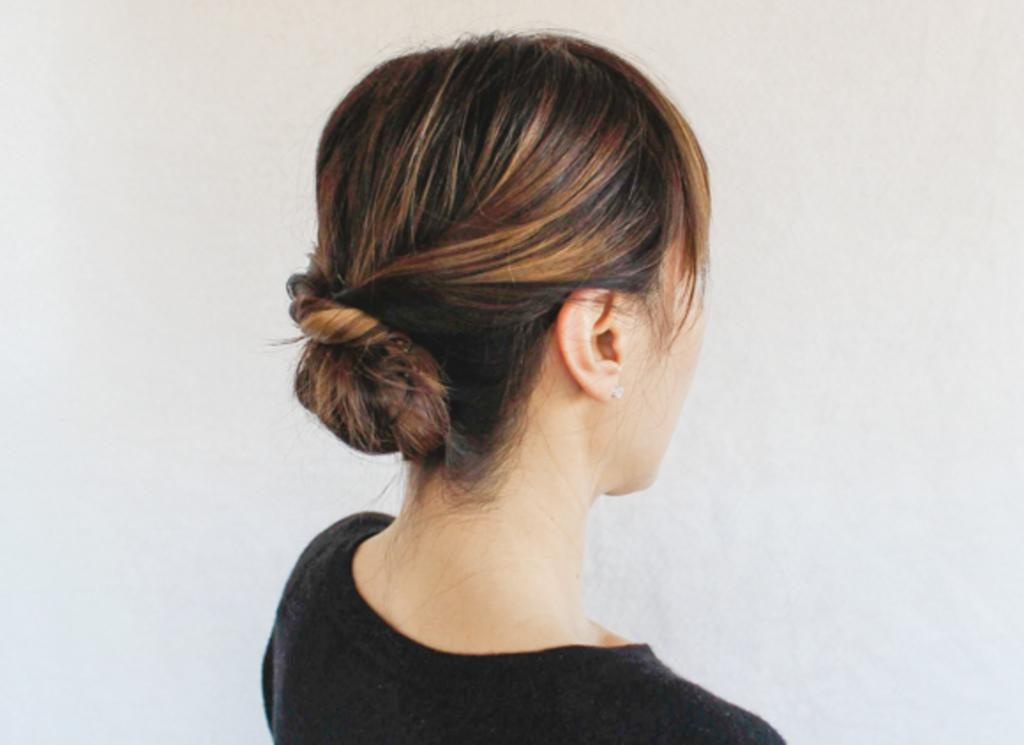Who is the main subject in the image? There is a girl in the image. What is the girl wearing? The girl is wearing a black dress. What else can be seen about the girl's appearance in the image? The girl's hair is visible in the image. What type of butter is being used to style the girl's hair in the image? There is no butter present in the image, and the girl's hair is not being styled with any butter. 